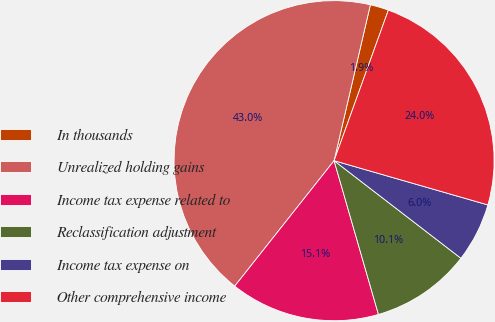<chart> <loc_0><loc_0><loc_500><loc_500><pie_chart><fcel>In thousands<fcel>Unrealized holding gains<fcel>Income tax expense related to<fcel>Reclassification adjustment<fcel>Income tax expense on<fcel>Other comprehensive income<nl><fcel>1.87%<fcel>42.98%<fcel>15.13%<fcel>10.09%<fcel>5.98%<fcel>23.95%<nl></chart> 